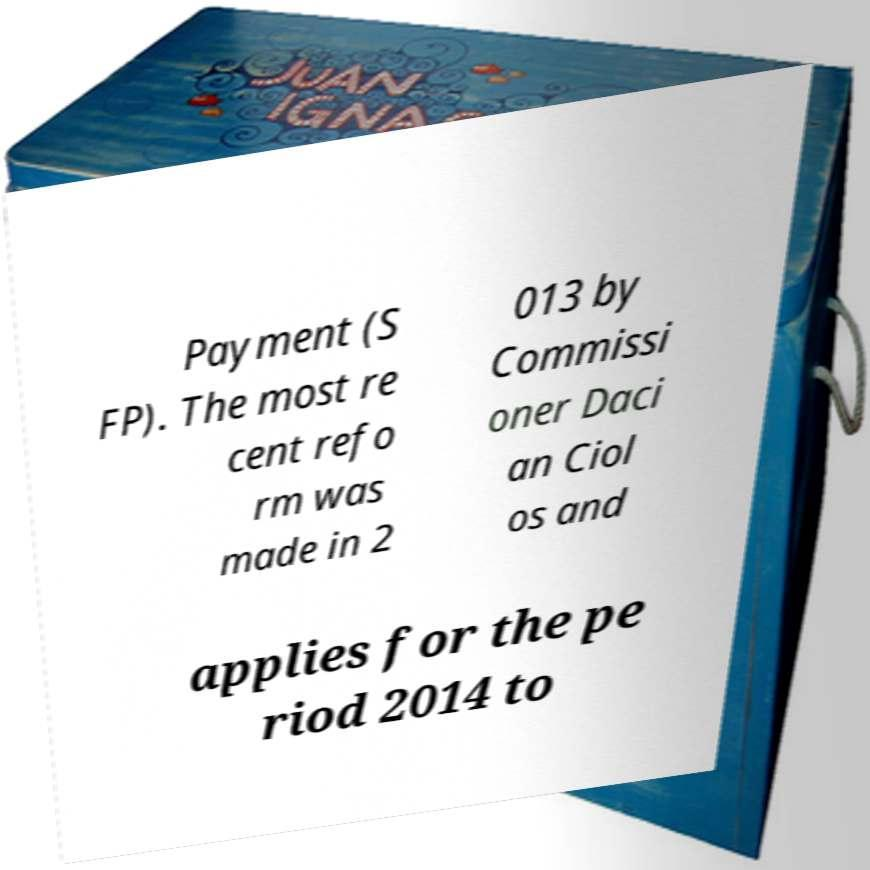There's text embedded in this image that I need extracted. Can you transcribe it verbatim? Payment (S FP). The most re cent refo rm was made in 2 013 by Commissi oner Daci an Ciol os and applies for the pe riod 2014 to 